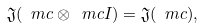Convert formula to latex. <formula><loc_0><loc_0><loc_500><loc_500>\mathfrak J ( \ m c \otimes \ m c I ) = \mathfrak J ( \ m c ) ,</formula> 